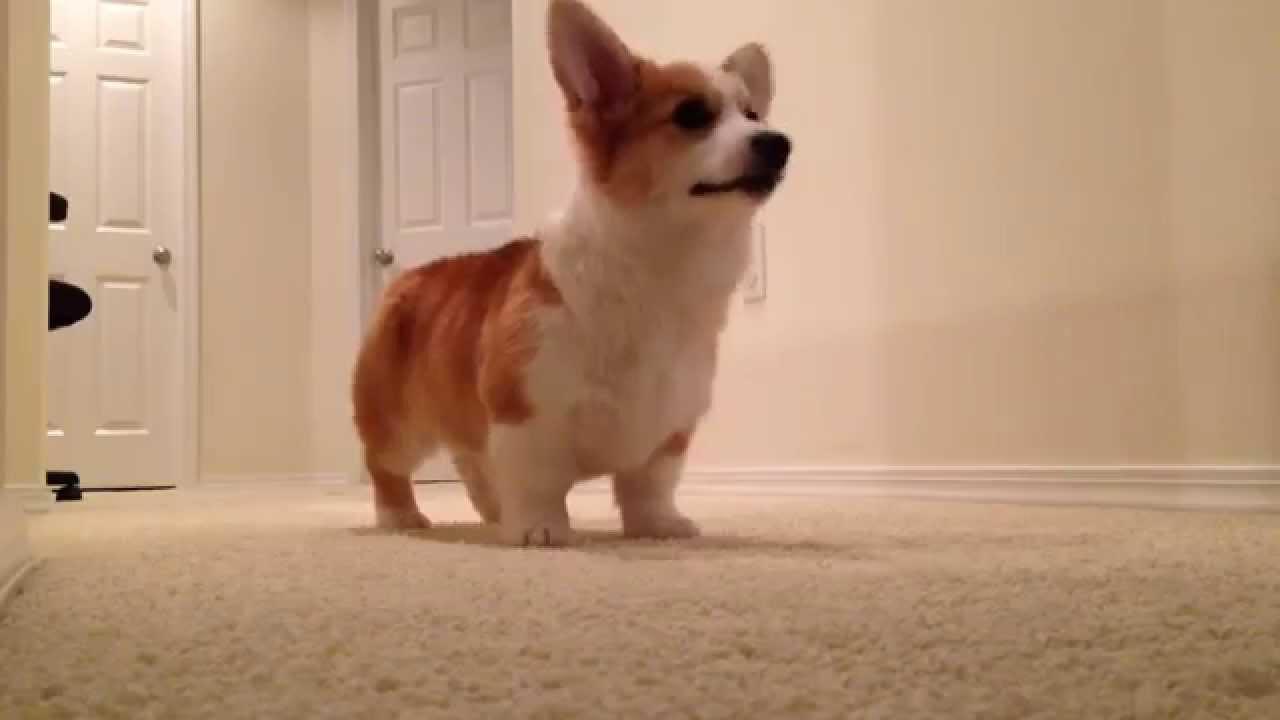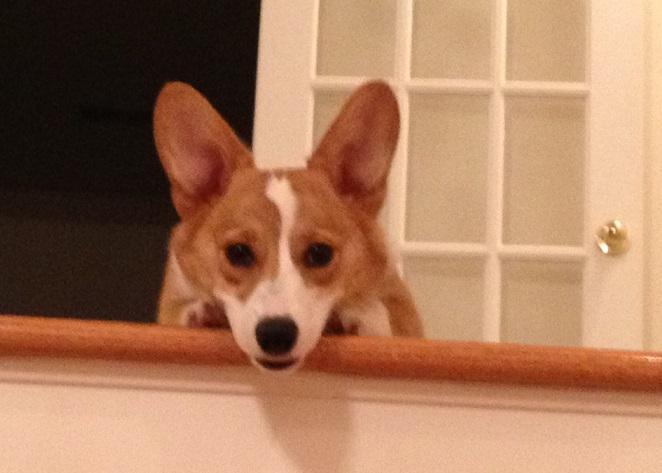The first image is the image on the left, the second image is the image on the right. Examine the images to the left and right. Is the description "One dog has its tongue out." accurate? Answer yes or no. No. The first image is the image on the left, the second image is the image on the right. For the images shown, is this caption "One image contains a tri-color dog that is not reclining and has its body angled to the right." true? Answer yes or no. No. 